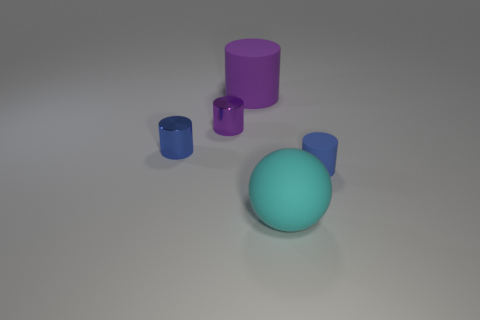Is the number of big spheres that are to the right of the small blue shiny cylinder greater than the number of cylinders on the right side of the small rubber cylinder?
Provide a succinct answer. Yes. What is the shape of the matte object that is in front of the small cylinder that is in front of the thing that is left of the small purple metal thing?
Provide a short and direct response. Sphere. There is a matte object to the right of the large rubber thing that is in front of the tiny blue rubber cylinder; what shape is it?
Your answer should be very brief. Cylinder. Are there any cylinders that have the same material as the sphere?
Offer a terse response. Yes. What size is the thing that is the same color as the large cylinder?
Offer a very short reply. Small. What number of blue objects are large spheres or matte cylinders?
Provide a short and direct response. 1. Is there a tiny metal object of the same color as the large rubber cylinder?
Give a very brief answer. Yes. What is the size of the purple cylinder that is the same material as the big ball?
Make the answer very short. Large. What number of spheres are tiny brown matte objects or big cyan objects?
Offer a terse response. 1. Is the number of balls greater than the number of tiny brown metallic balls?
Provide a short and direct response. Yes. 